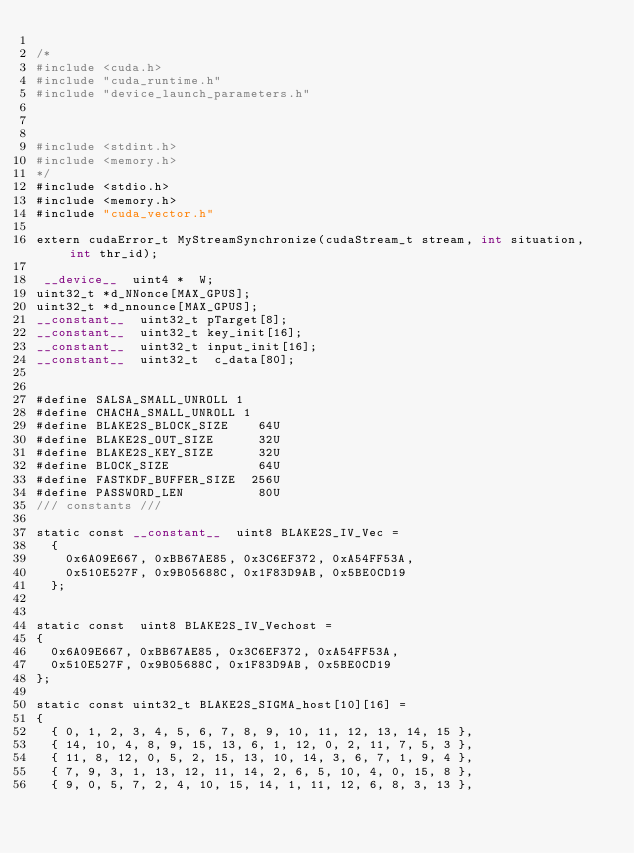Convert code to text. <code><loc_0><loc_0><loc_500><loc_500><_Cuda_>
/*
#include <cuda.h>
#include "cuda_runtime.h"
#include "device_launch_parameters.h"



#include <stdint.h>
#include <memory.h>
*/
#include <stdio.h>
#include <memory.h>
#include "cuda_vector.h" 
 
extern cudaError_t MyStreamSynchronize(cudaStream_t stream, int situation, int thr_id);

 __device__  uint4 *  W;
uint32_t *d_NNonce[MAX_GPUS];
uint32_t *d_nnounce[MAX_GPUS];
__constant__  uint32_t pTarget[8];
__constant__  uint32_t key_init[16]; 
__constant__  uint32_t input_init[16];
__constant__  uint32_t  c_data[80];


#define SALSA_SMALL_UNROLL 1
#define CHACHA_SMALL_UNROLL 1
#define BLAKE2S_BLOCK_SIZE    64U 
#define BLAKE2S_OUT_SIZE      32U
#define BLAKE2S_KEY_SIZE      32U
#define BLOCK_SIZE            64U
#define FASTKDF_BUFFER_SIZE  256U
#define PASSWORD_LEN          80U
/// constants ///

static const __constant__  uint8 BLAKE2S_IV_Vec =
	{
		0x6A09E667, 0xBB67AE85, 0x3C6EF372, 0xA54FF53A,
		0x510E527F, 0x9B05688C, 0x1F83D9AB, 0x5BE0CD19
	};


static const  uint8 BLAKE2S_IV_Vechost =
{
	0x6A09E667, 0xBB67AE85, 0x3C6EF372, 0xA54FF53A,
	0x510E527F, 0x9B05688C, 0x1F83D9AB, 0x5BE0CD19
};

static const uint32_t BLAKE2S_SIGMA_host[10][16] =
{
	{ 0, 1, 2, 3, 4, 5, 6, 7, 8, 9, 10, 11, 12, 13, 14, 15 },
	{ 14, 10, 4, 8, 9, 15, 13, 6, 1, 12, 0, 2, 11, 7, 5, 3 },
	{ 11, 8, 12, 0, 5, 2, 15, 13, 10, 14, 3, 6, 7, 1, 9, 4 },
	{ 7, 9, 3, 1, 13, 12, 11, 14, 2, 6, 5, 10, 4, 0, 15, 8 },
	{ 9, 0, 5, 7, 2, 4, 10, 15, 14, 1, 11, 12, 6, 8, 3, 13 },</code> 